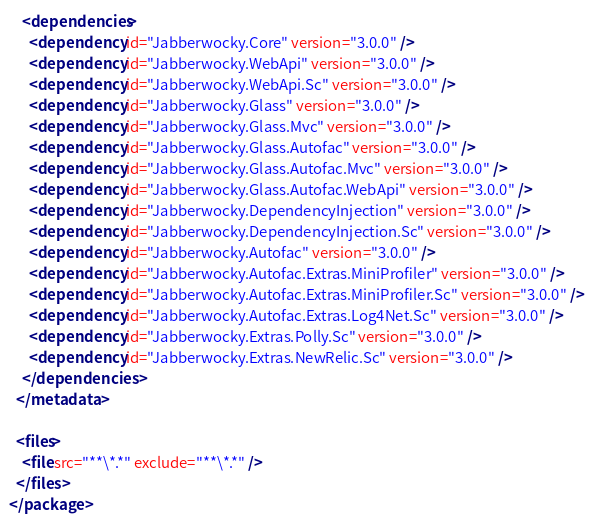Convert code to text. <code><loc_0><loc_0><loc_500><loc_500><_XML_>
    <dependencies>
      <dependency id="Jabberwocky.Core" version="3.0.0" />
      <dependency id="Jabberwocky.WebApi" version="3.0.0" />
      <dependency id="Jabberwocky.WebApi.Sc" version="3.0.0" />
      <dependency id="Jabberwocky.Glass" version="3.0.0" />
      <dependency id="Jabberwocky.Glass.Mvc" version="3.0.0" />
      <dependency id="Jabberwocky.Glass.Autofac" version="3.0.0" />
      <dependency id="Jabberwocky.Glass.Autofac.Mvc" version="3.0.0" />
      <dependency id="Jabberwocky.Glass.Autofac.WebApi" version="3.0.0" />
      <dependency id="Jabberwocky.DependencyInjection" version="3.0.0" />
      <dependency id="Jabberwocky.DependencyInjection.Sc" version="3.0.0" />
      <dependency id="Jabberwocky.Autofac" version="3.0.0" />
      <dependency id="Jabberwocky.Autofac.Extras.MiniProfiler" version="3.0.0" />
      <dependency id="Jabberwocky.Autofac.Extras.MiniProfiler.Sc" version="3.0.0" />
      <dependency id="Jabberwocky.Autofac.Extras.Log4Net.Sc" version="3.0.0" />
      <dependency id="Jabberwocky.Extras.Polly.Sc" version="3.0.0" />
      <dependency id="Jabberwocky.Extras.NewRelic.Sc" version="3.0.0" />
    </dependencies>
  </metadata>

  <files>
    <file src="**\*.*" exclude="**\*.*" />
  </files>
</package></code> 